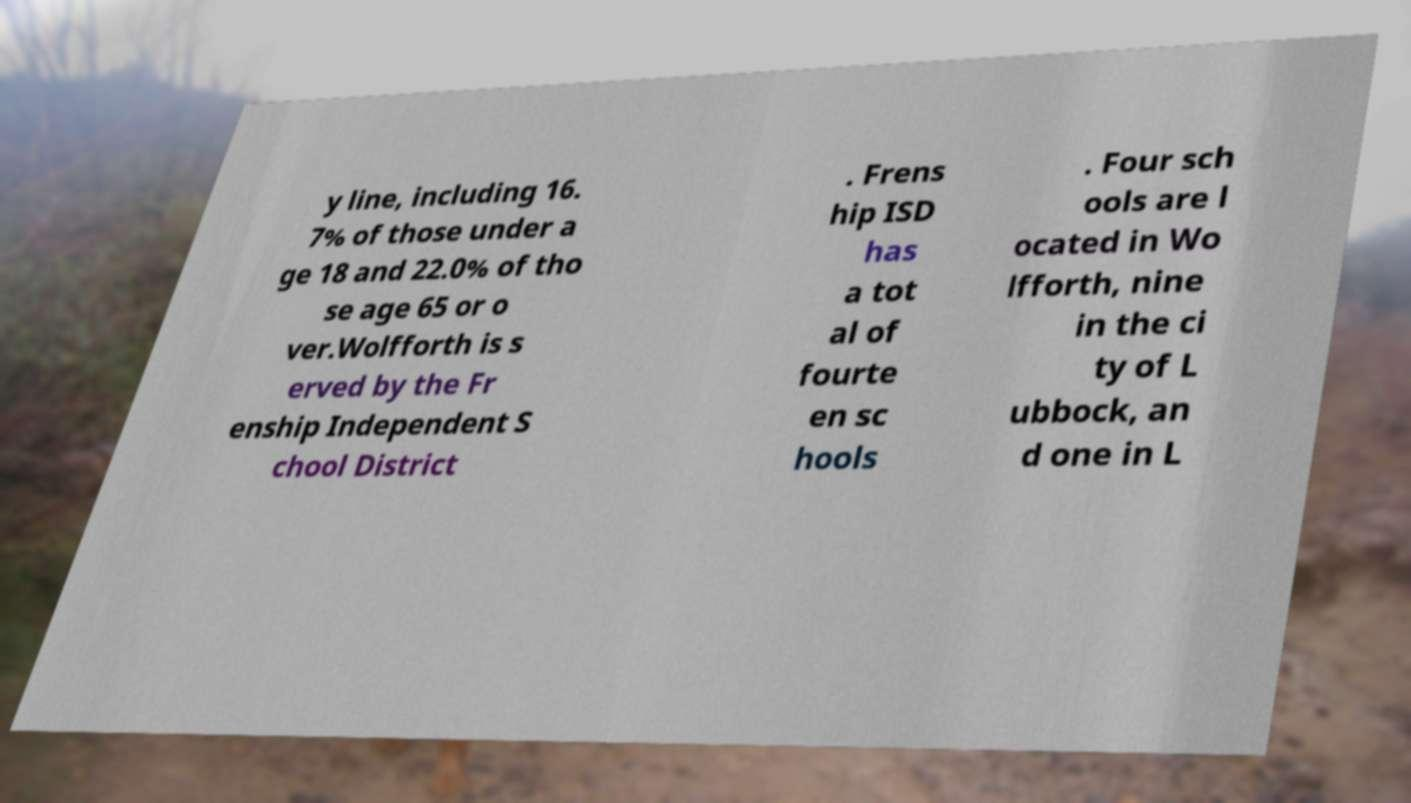Can you accurately transcribe the text from the provided image for me? y line, including 16. 7% of those under a ge 18 and 22.0% of tho se age 65 or o ver.Wolfforth is s erved by the Fr enship Independent S chool District . Frens hip ISD has a tot al of fourte en sc hools . Four sch ools are l ocated in Wo lfforth, nine in the ci ty of L ubbock, an d one in L 